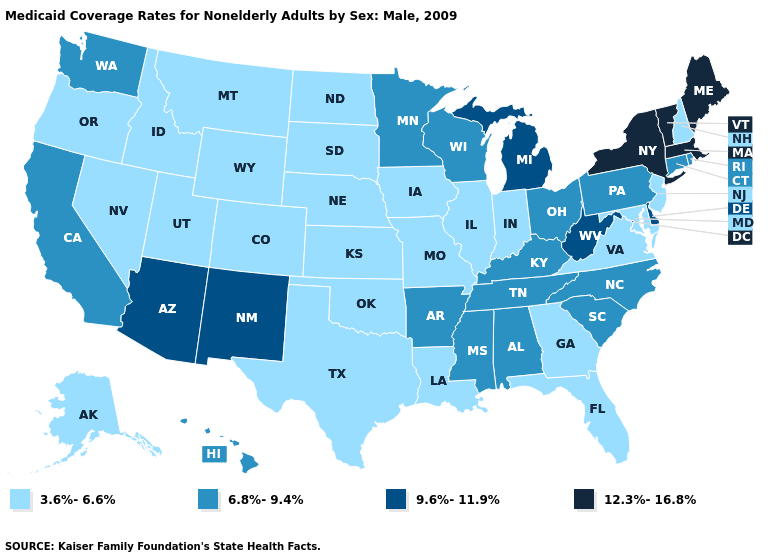What is the lowest value in the South?
Write a very short answer. 3.6%-6.6%. Name the states that have a value in the range 3.6%-6.6%?
Concise answer only. Alaska, Colorado, Florida, Georgia, Idaho, Illinois, Indiana, Iowa, Kansas, Louisiana, Maryland, Missouri, Montana, Nebraska, Nevada, New Hampshire, New Jersey, North Dakota, Oklahoma, Oregon, South Dakota, Texas, Utah, Virginia, Wyoming. Is the legend a continuous bar?
Answer briefly. No. Does Indiana have the same value as Minnesota?
Write a very short answer. No. Among the states that border Florida , does Georgia have the lowest value?
Short answer required. Yes. Does Missouri have the lowest value in the MidWest?
Concise answer only. Yes. Name the states that have a value in the range 9.6%-11.9%?
Be succinct. Arizona, Delaware, Michigan, New Mexico, West Virginia. Name the states that have a value in the range 3.6%-6.6%?
Answer briefly. Alaska, Colorado, Florida, Georgia, Idaho, Illinois, Indiana, Iowa, Kansas, Louisiana, Maryland, Missouri, Montana, Nebraska, Nevada, New Hampshire, New Jersey, North Dakota, Oklahoma, Oregon, South Dakota, Texas, Utah, Virginia, Wyoming. What is the value of Oklahoma?
Keep it brief. 3.6%-6.6%. Name the states that have a value in the range 12.3%-16.8%?
Be succinct. Maine, Massachusetts, New York, Vermont. Does Minnesota have a higher value than Utah?
Write a very short answer. Yes. Does the first symbol in the legend represent the smallest category?
Give a very brief answer. Yes. What is the value of Arkansas?
Keep it brief. 6.8%-9.4%. Name the states that have a value in the range 9.6%-11.9%?
Be succinct. Arizona, Delaware, Michigan, New Mexico, West Virginia. 